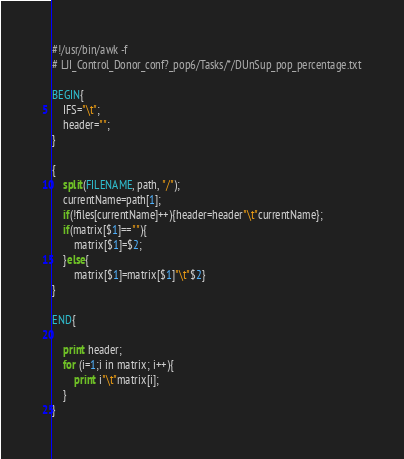<code> <loc_0><loc_0><loc_500><loc_500><_Awk_>#!/usr/bin/awk -f
# LJI_Control_Donor_conf?_pop6/Tasks/*/DUnSup_pop_percentage.txt

BEGIN{
	IFS="\t";
	header="";
}

{
	split(FILENAME, path, "/");
	currentName=path[1];
	if(!files[currentName]++){header=header"\t"currentName};
	if(matrix[$1]==""){
		matrix[$1]=$2;
	}else{
		matrix[$1]=matrix[$1]"\t"$2}
}

END{
	
	print header;
	for (i=1;i in matrix; i++){
		print i"\t"matrix[i];
	}
}
</code> 